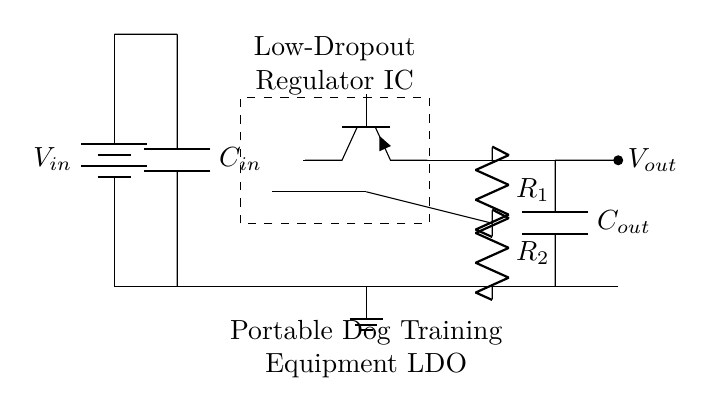What type of regulator is shown in this circuit? The circuit diagram illustrates a low-dropout regulator, indicated by the label in the diagram and the presence of a pass transistor specific to LDOs.
Answer: low-dropout regulator What is the function of the capacitor labeled C_in? The input capacitor (C_in) is used to stabilize the input voltage and reduce noise in the circuit, ensuring the LDO operates efficiently.
Answer: stabilize input voltage How many resistors are present in the feedback network? The feedback network consists of two resistors (R_1 and R_2), which are used to set the output voltage of the LDO.
Answer: two What is the purpose of the error amplifier in this circuit? The error amplifier compares the output voltage to a reference voltage and modulates the pass transistor to maintain a stable output voltage under varying load conditions.
Answer: maintain stable output voltage What happens if C_out is not included in the circuit? Omitting the output capacitor (C_out) can lead to instability in the output voltage, as it provides a means to reduce output noise and stabilize the voltage during load changes.
Answer: instability What is the output voltage node in the circuit? The output voltage node is marked as V_out, which is the point where the regulated output voltage is provided to the load.
Answer: V_out What is the role of the pass transistor shown in the circuit? The pass transistor regulates the output voltage by controlling the current flow based on the feedback from the output, essential in achieving low dropout operation.
Answer: regulate output voltage 